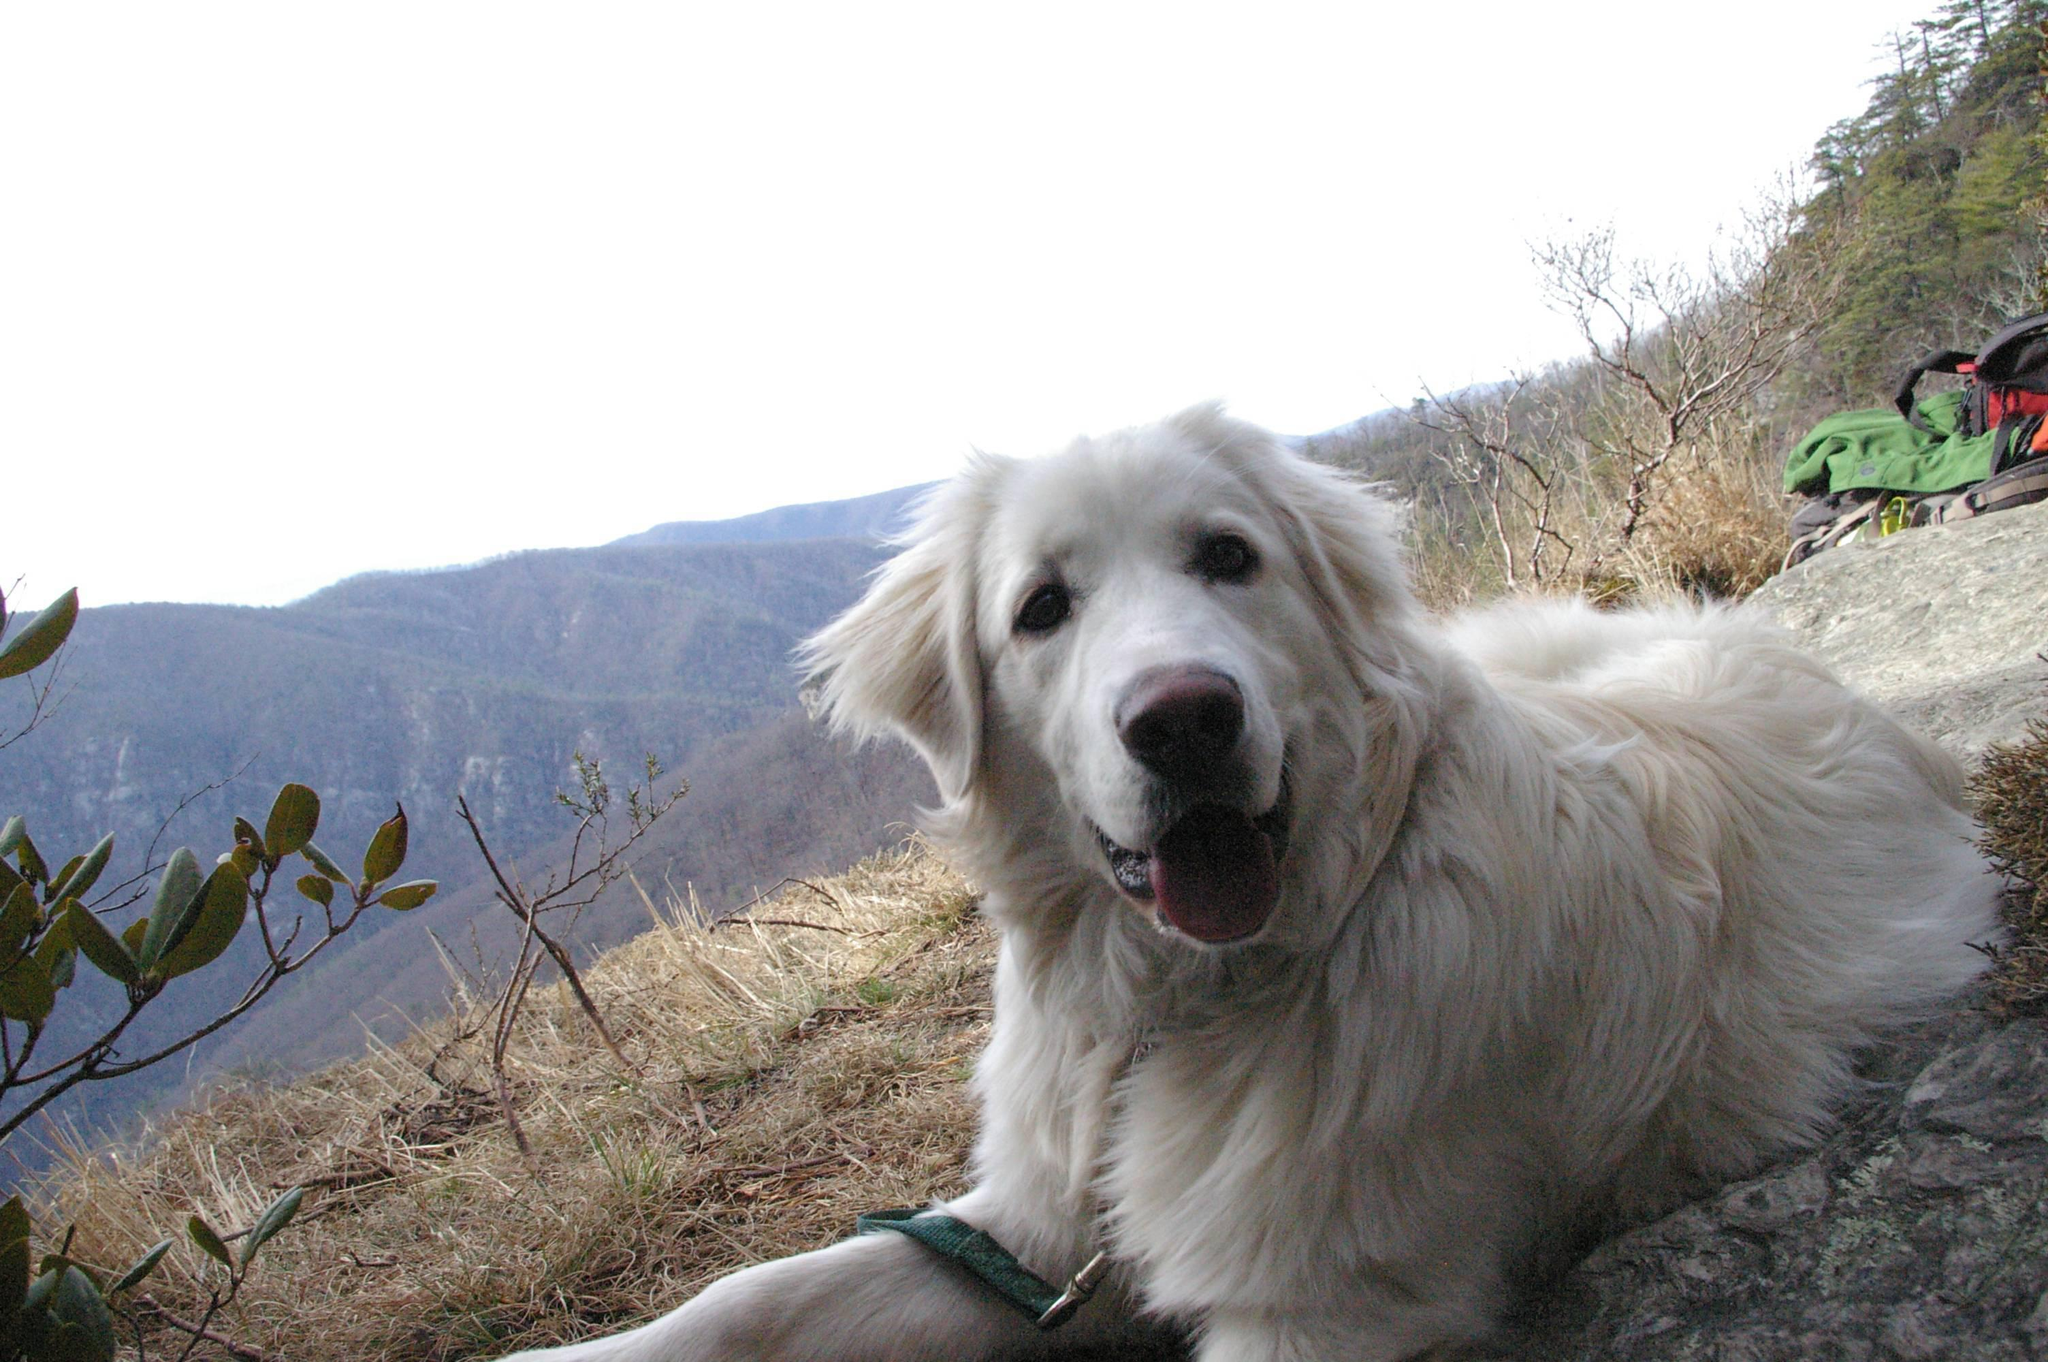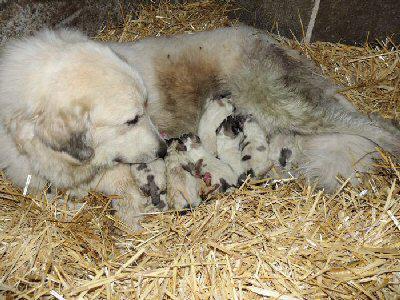The first image is the image on the left, the second image is the image on the right. Evaluate the accuracy of this statement regarding the images: "There is a lone dog facing the camera in one image and a dog with at least one puppy in the other image.". Is it true? Answer yes or no. Yes. The first image is the image on the left, the second image is the image on the right. Considering the images on both sides, is "Every image contains only one dog" valid? Answer yes or no. No. 